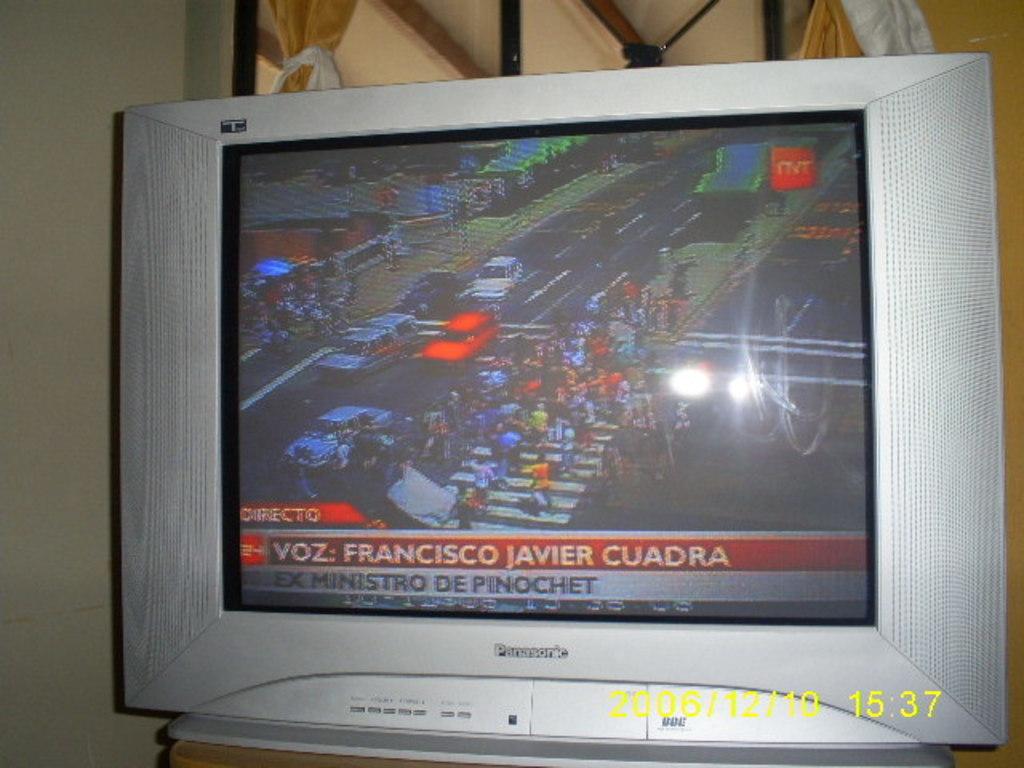What person is the news about?
Your answer should be very brief. Francisco javier cuadra. What time was this picture taken?
Make the answer very short. 15:37. 